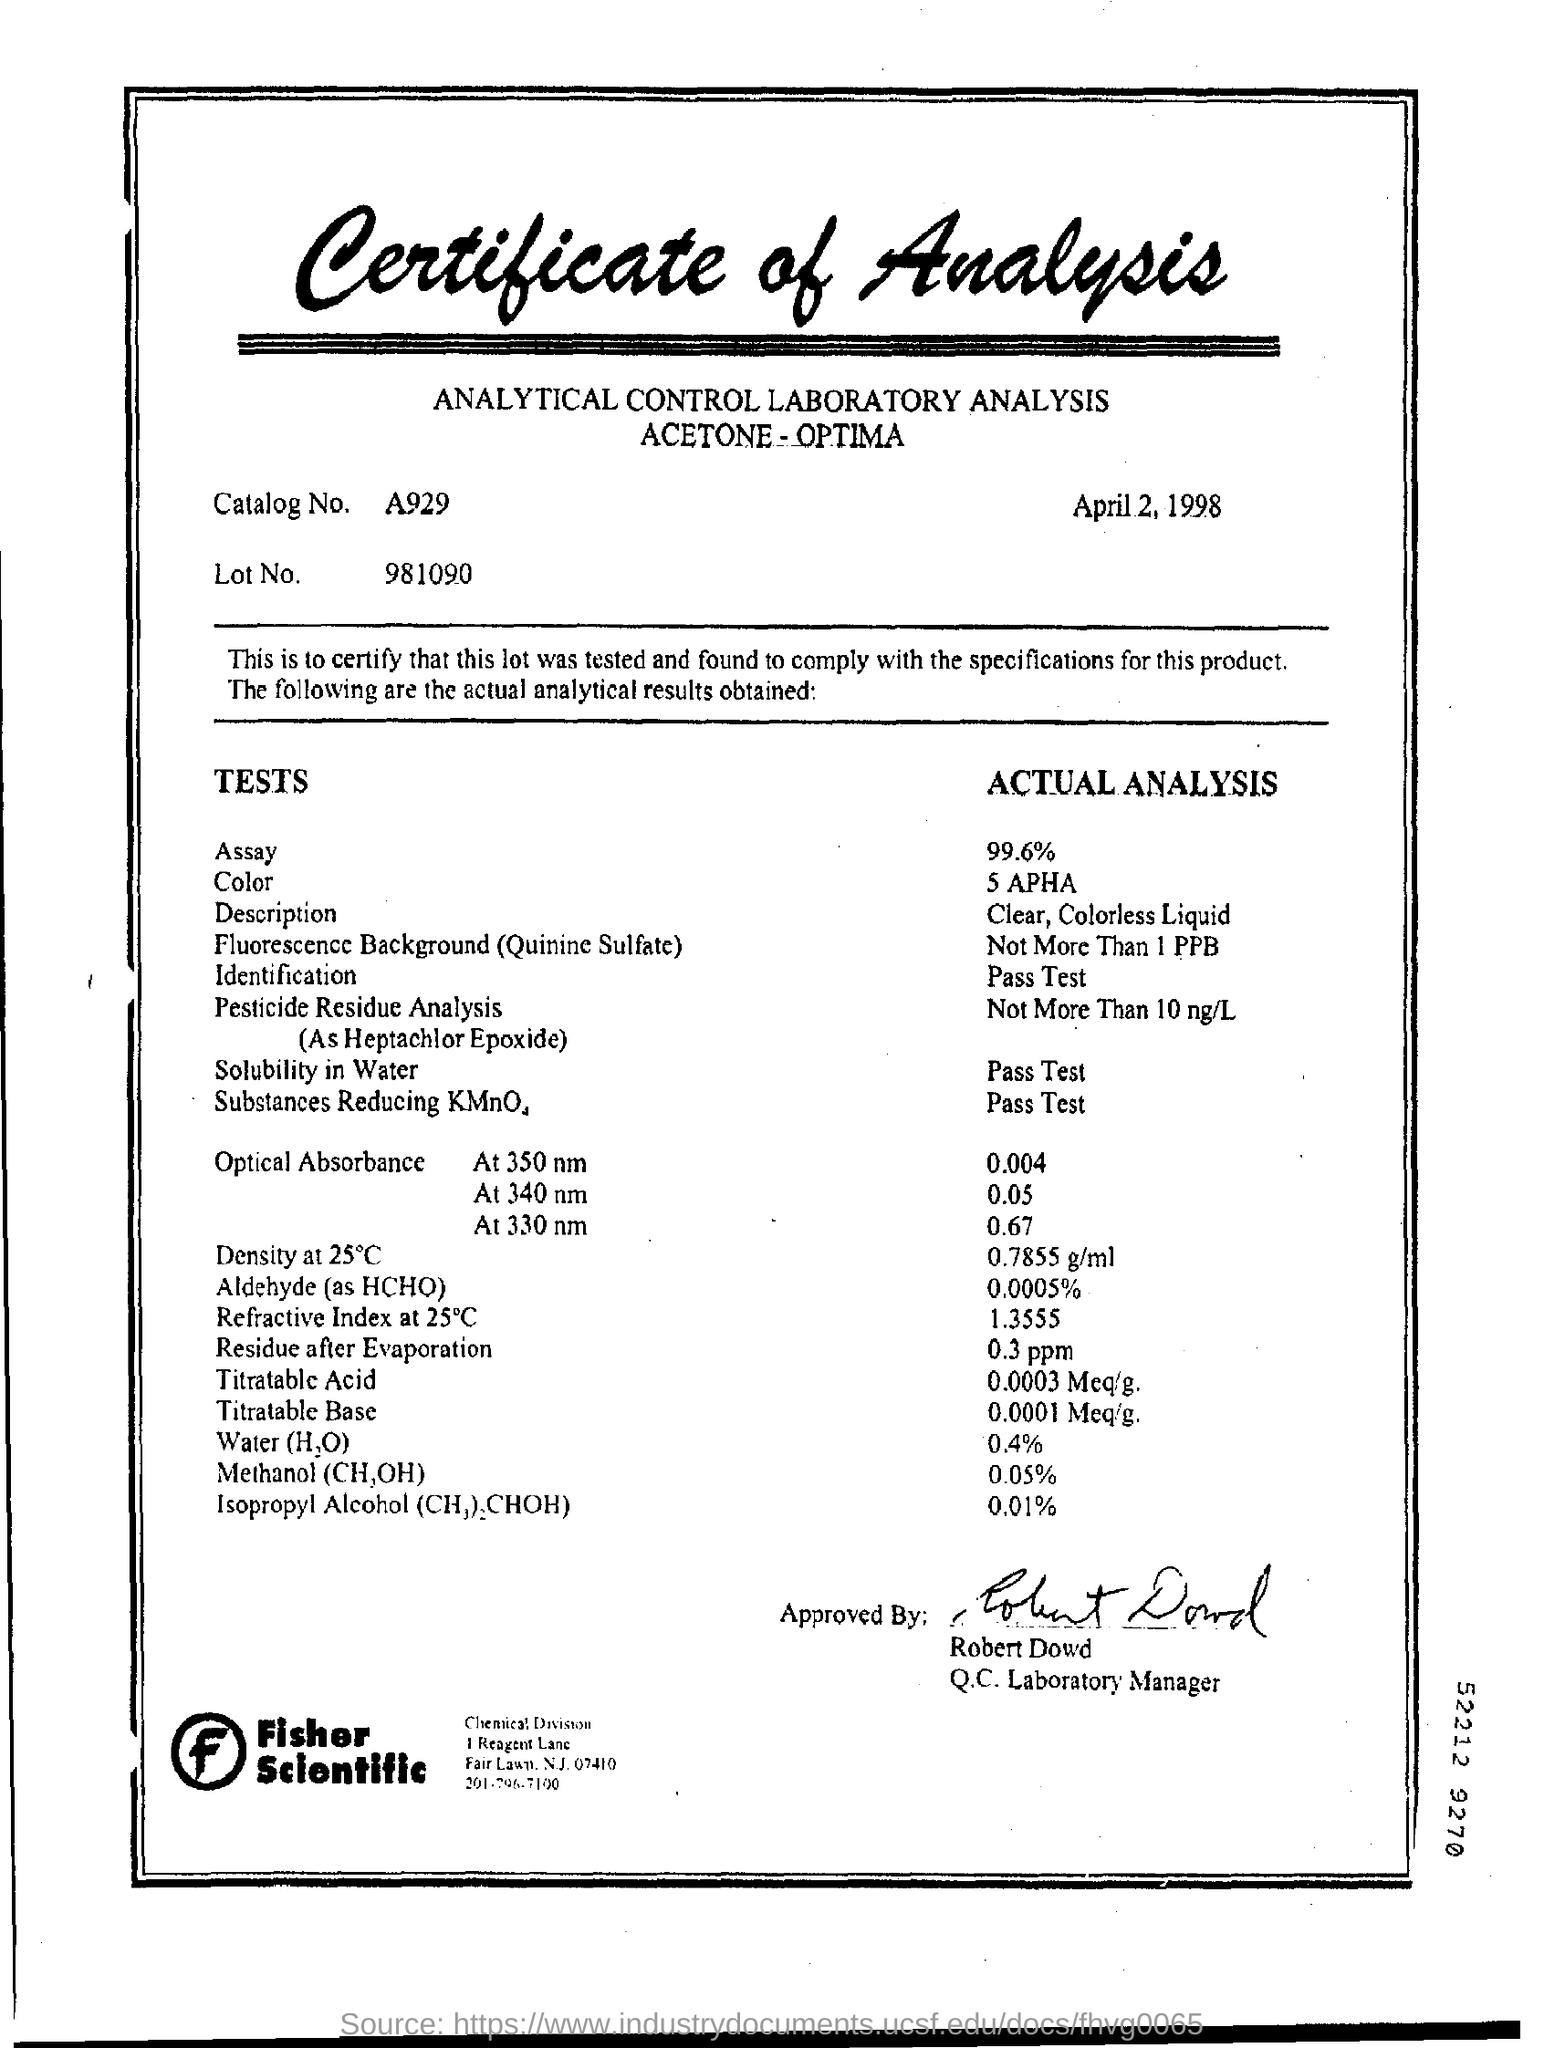List a handful of essential elements in this visual. What is the Lot Number? 981090..." is a question asking for information about a specific lot number. The residue that remains after evaporation has a value of 0.3 parts per million (ppm). The value of the assay is 99.6%. What is the catalog number? A929... The analysis is dated April 2, 1998. 